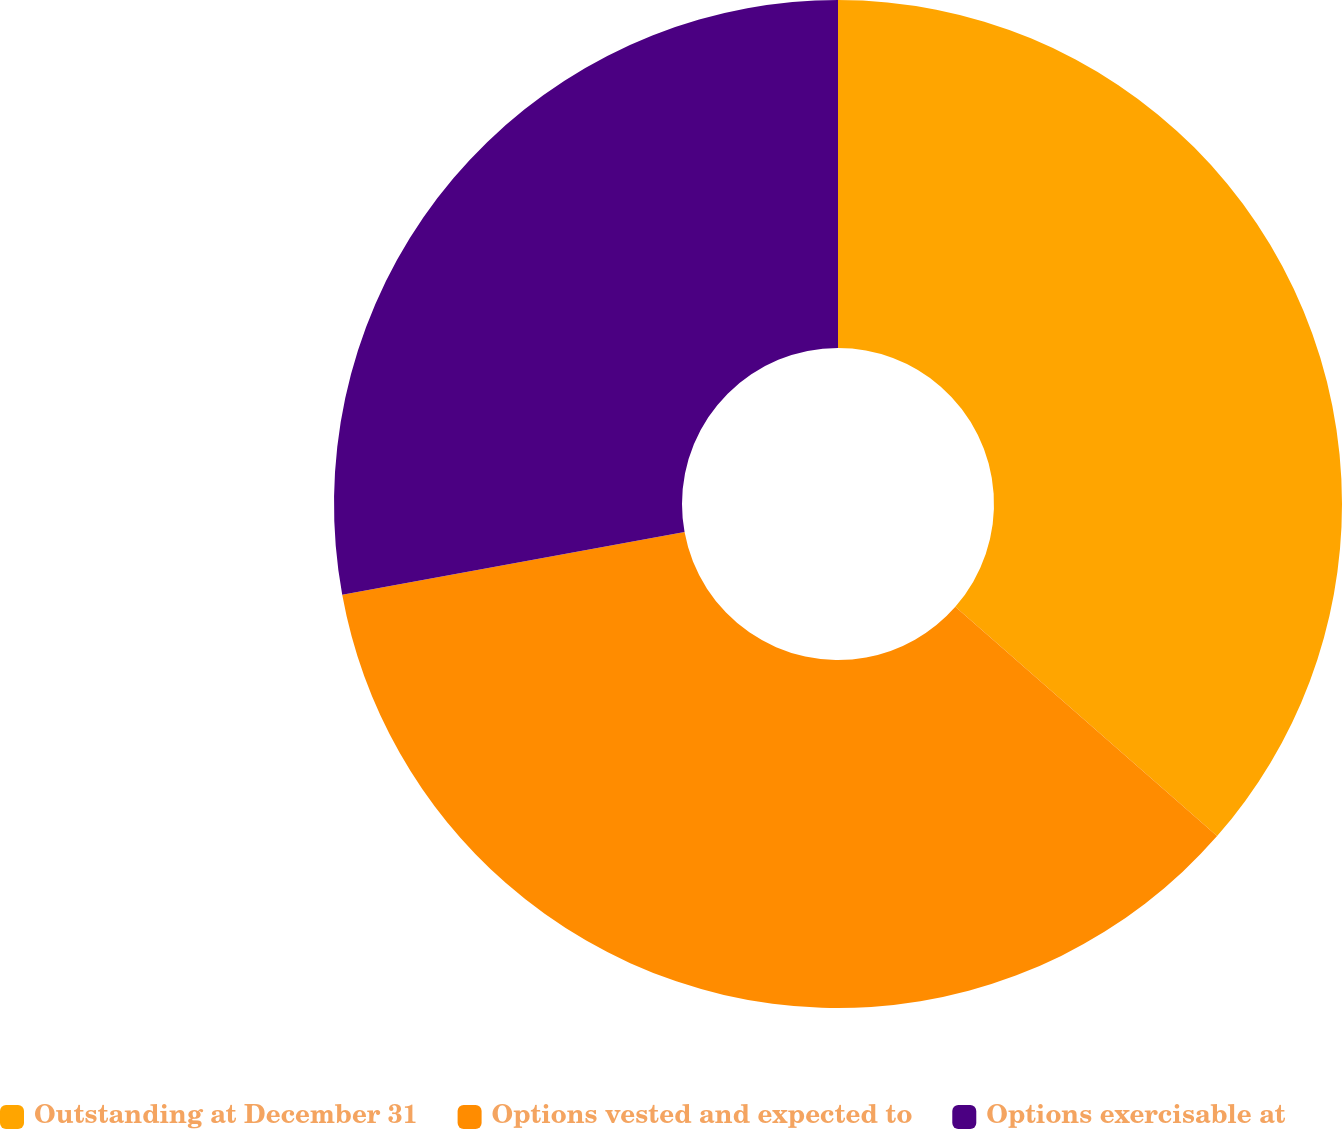Convert chart to OTSL. <chart><loc_0><loc_0><loc_500><loc_500><pie_chart><fcel>Outstanding at December 31<fcel>Options vested and expected to<fcel>Options exercisable at<nl><fcel>36.45%<fcel>35.67%<fcel>27.88%<nl></chart> 